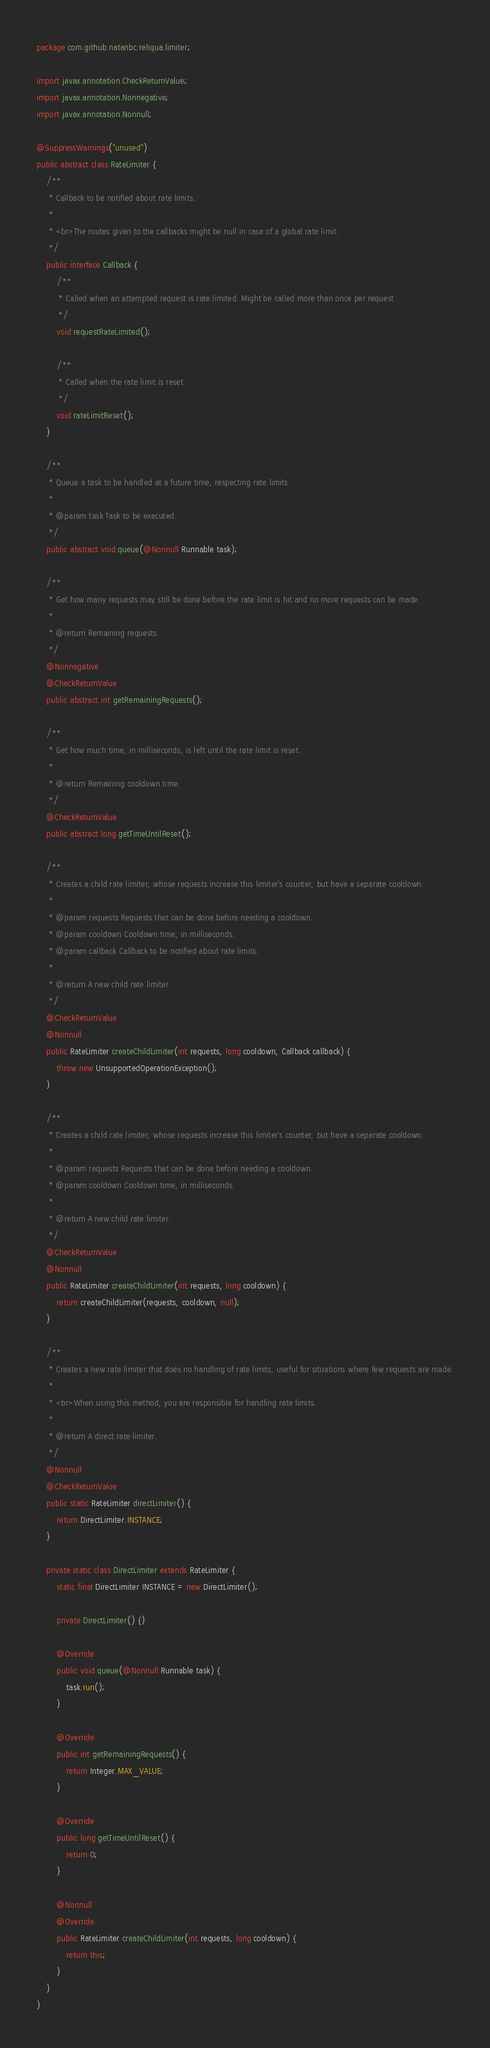<code> <loc_0><loc_0><loc_500><loc_500><_Java_>package com.github.natanbc.reliqua.limiter;

import javax.annotation.CheckReturnValue;
import javax.annotation.Nonnegative;
import javax.annotation.Nonnull;

@SuppressWarnings("unused")
public abstract class RateLimiter {
    /**
     * Callback to be notified about rate limits.
     *
     * <br>The routes given to the callbacks might be null in case of a global rate limit.
     */
    public interface Callback {
        /**
         * Called when an attempted request is rate limited. Might be called more than once per request
         */
        void requestRateLimited();

        /**
         * Called when the rate limit is reset.
         */
        void rateLimitReset();
    }

    /**
     * Queue a task to be handled at a future time, respecting rate limits.
     *
     * @param task Task to be executed.
     */
    public abstract void queue(@Nonnull Runnable task);

    /**
     * Get how many requests may still be done before the rate limit is hit and no more requests can be made.
     *
     * @return Remaining requests.
     */
    @Nonnegative
    @CheckReturnValue
    public abstract int getRemainingRequests();

    /**
     * Get how much time, in milliseconds, is left until the rate limit is reset.
     *
     * @return Remaining cooldown time.
     */
    @CheckReturnValue
    public abstract long getTimeUntilReset();

    /**
     * Creates a child rate limiter, whose requests increase this limiter's counter, but have a separate cooldown.
     *
     * @param requests Requests that can be done before needing a cooldown.
     * @param cooldown Cooldown time, in milliseconds.
     * @param callback Callback to be notified about rate limits.
     *
     * @return A new child rate limiter.
     */
    @CheckReturnValue
    @Nonnull
    public RateLimiter createChildLimiter(int requests, long cooldown, Callback callback) {
        throw new UnsupportedOperationException();
    }

    /**
     * Creates a child rate limiter, whose requests increase this limiter's counter, but have a separate cooldown.
     *
     * @param requests Requests that can be done before needing a cooldown.
     * @param cooldown Cooldown time, in milliseconds.
     *
     * @return A new child rate limiter.
     */
    @CheckReturnValue
    @Nonnull
    public RateLimiter createChildLimiter(int requests, long cooldown) {
        return createChildLimiter(requests, cooldown, null);
    }

    /**
     * Creates a new rate limiter that does no handling of rate limits, useful for situations where few requests are made.
     *
     * <br>When using this method, you are responsible for handling rate limits.
     *
     * @return A direct rate limiter.
     */
    @Nonnull
    @CheckReturnValue
    public static RateLimiter directLimiter() {
        return DirectLimiter.INSTANCE;
    }

    private static class DirectLimiter extends RateLimiter {
        static final DirectLimiter INSTANCE = new DirectLimiter();

        private DirectLimiter() {}

        @Override
        public void queue(@Nonnull Runnable task) {
            task.run();
        }

        @Override
        public int getRemainingRequests() {
            return Integer.MAX_VALUE;
        }

        @Override
        public long getTimeUntilReset() {
            return 0;
        }

        @Nonnull
        @Override
        public RateLimiter createChildLimiter(int requests, long cooldown) {
            return this;
        }
    }
}
</code> 